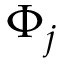Convert formula to latex. <formula><loc_0><loc_0><loc_500><loc_500>\Phi _ { j }</formula> 